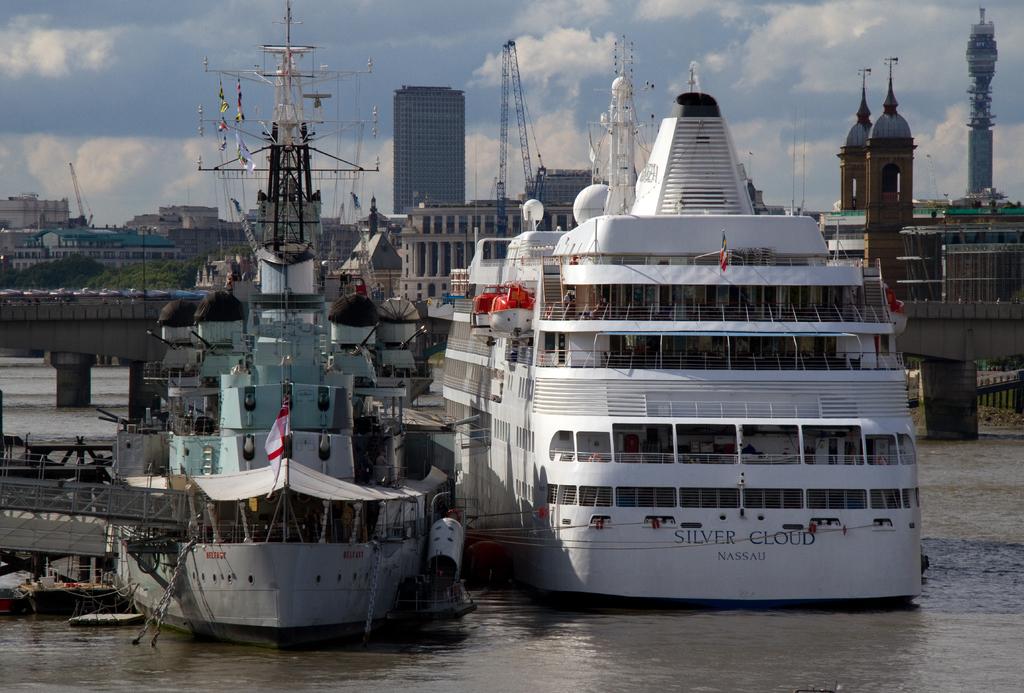What is the name on the front of the huge white boat / yacht?
Your answer should be compact. Silver cloud. 